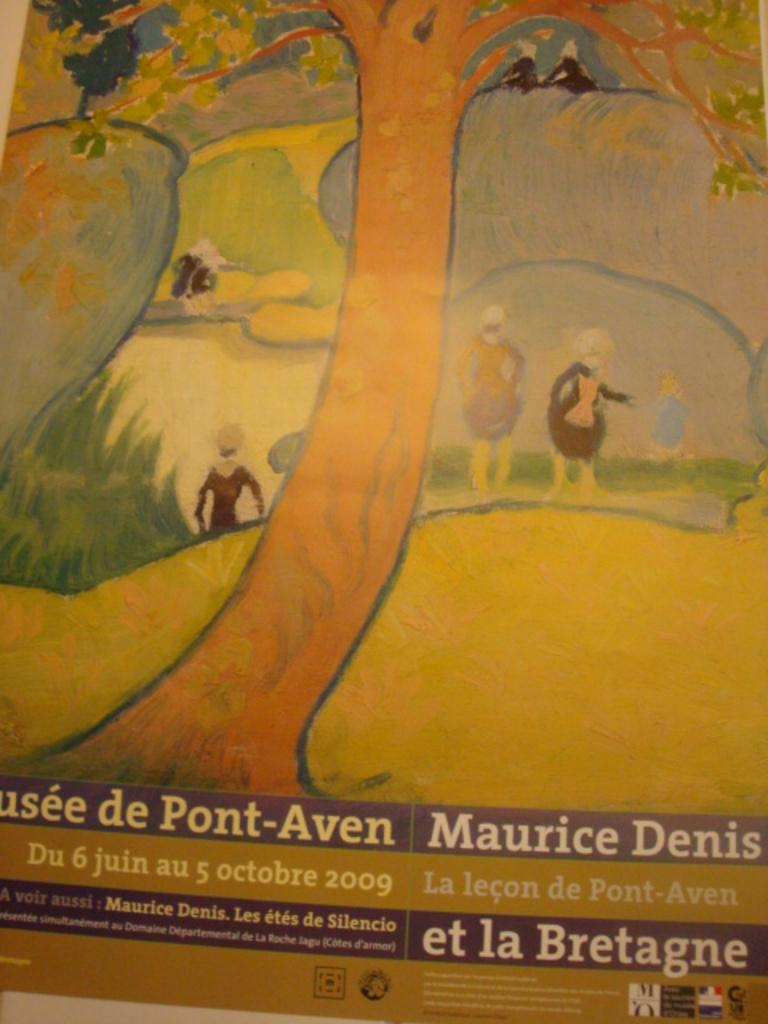<image>
Summarize the visual content of the image. a poster for Musee de Pont-Aven shows a tree and people under it 